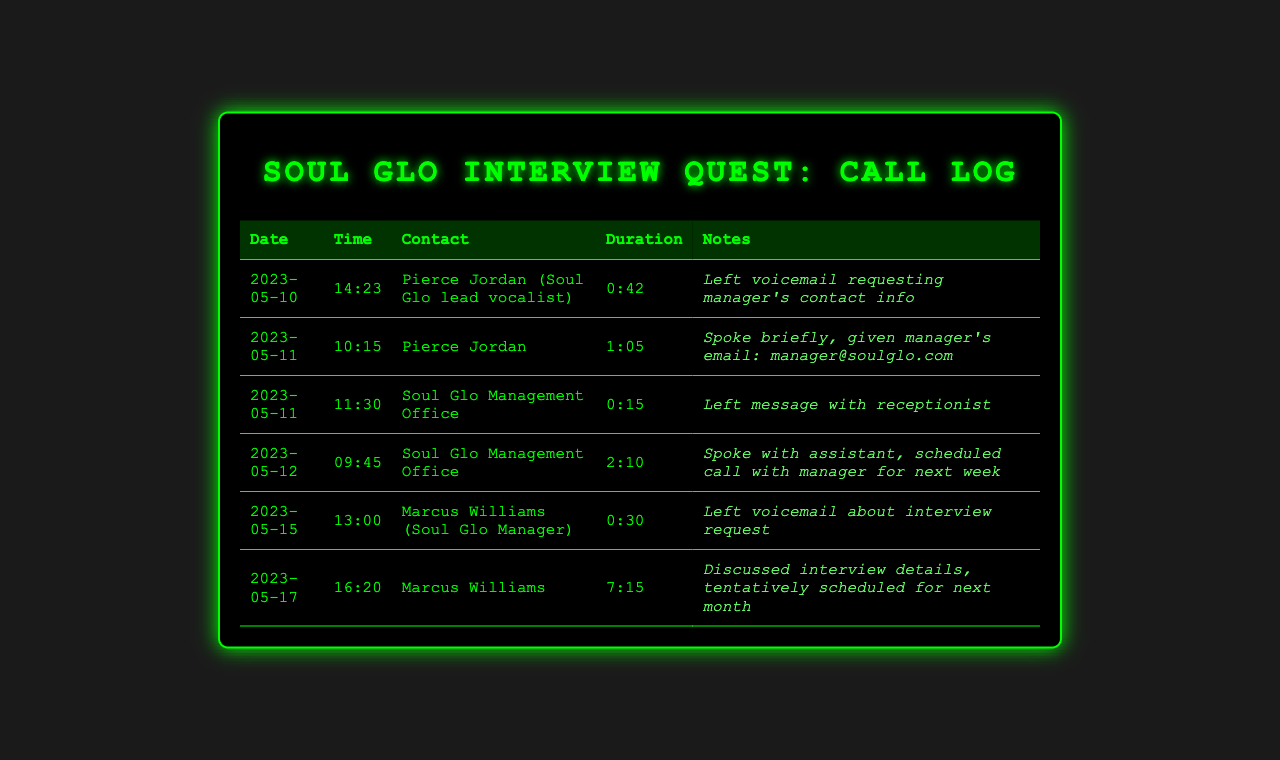What is the date of the first call? The first call occurred on the date specified in the document as 2023-05-10.
Answer: 2023-05-10 Who did Pierce Jordan give the manager's email to? Pierce Jordan provided the contact information during a conversation, and it can be found in the log of the call on 2023-05-11.
Answer: Soul Glo's fan What was the duration of the call with the manager on May 17? The duration of the call with Marcus Williams on May 17 can be retrieved from the document.
Answer: 7:15 What was scheduled during the call with the assistant on May 12? The log entry specifies that a call with the manager was scheduled, hence the answer is found in that entry.
Answer: Call with manager for next week How long did the call with the management office take on May 11? The answer can be found in the entry for that date, which states the call duration in minutes and seconds.
Answer: 0:15 What is the phone number for Marcus Williams? The document does not contain a phone number for Marcus Williams, as it's not included in the call log.
Answer: Not provided What action was taken during the call on May 15? The log states that a voicemail was left regarding the interview request during that call.
Answer: Left voicemail What contact method was used to reach the manager? The log entries indicate that a combination of voicemail and scheduled calls were used to reach the manager.
Answer: Voicemail and scheduled calls 